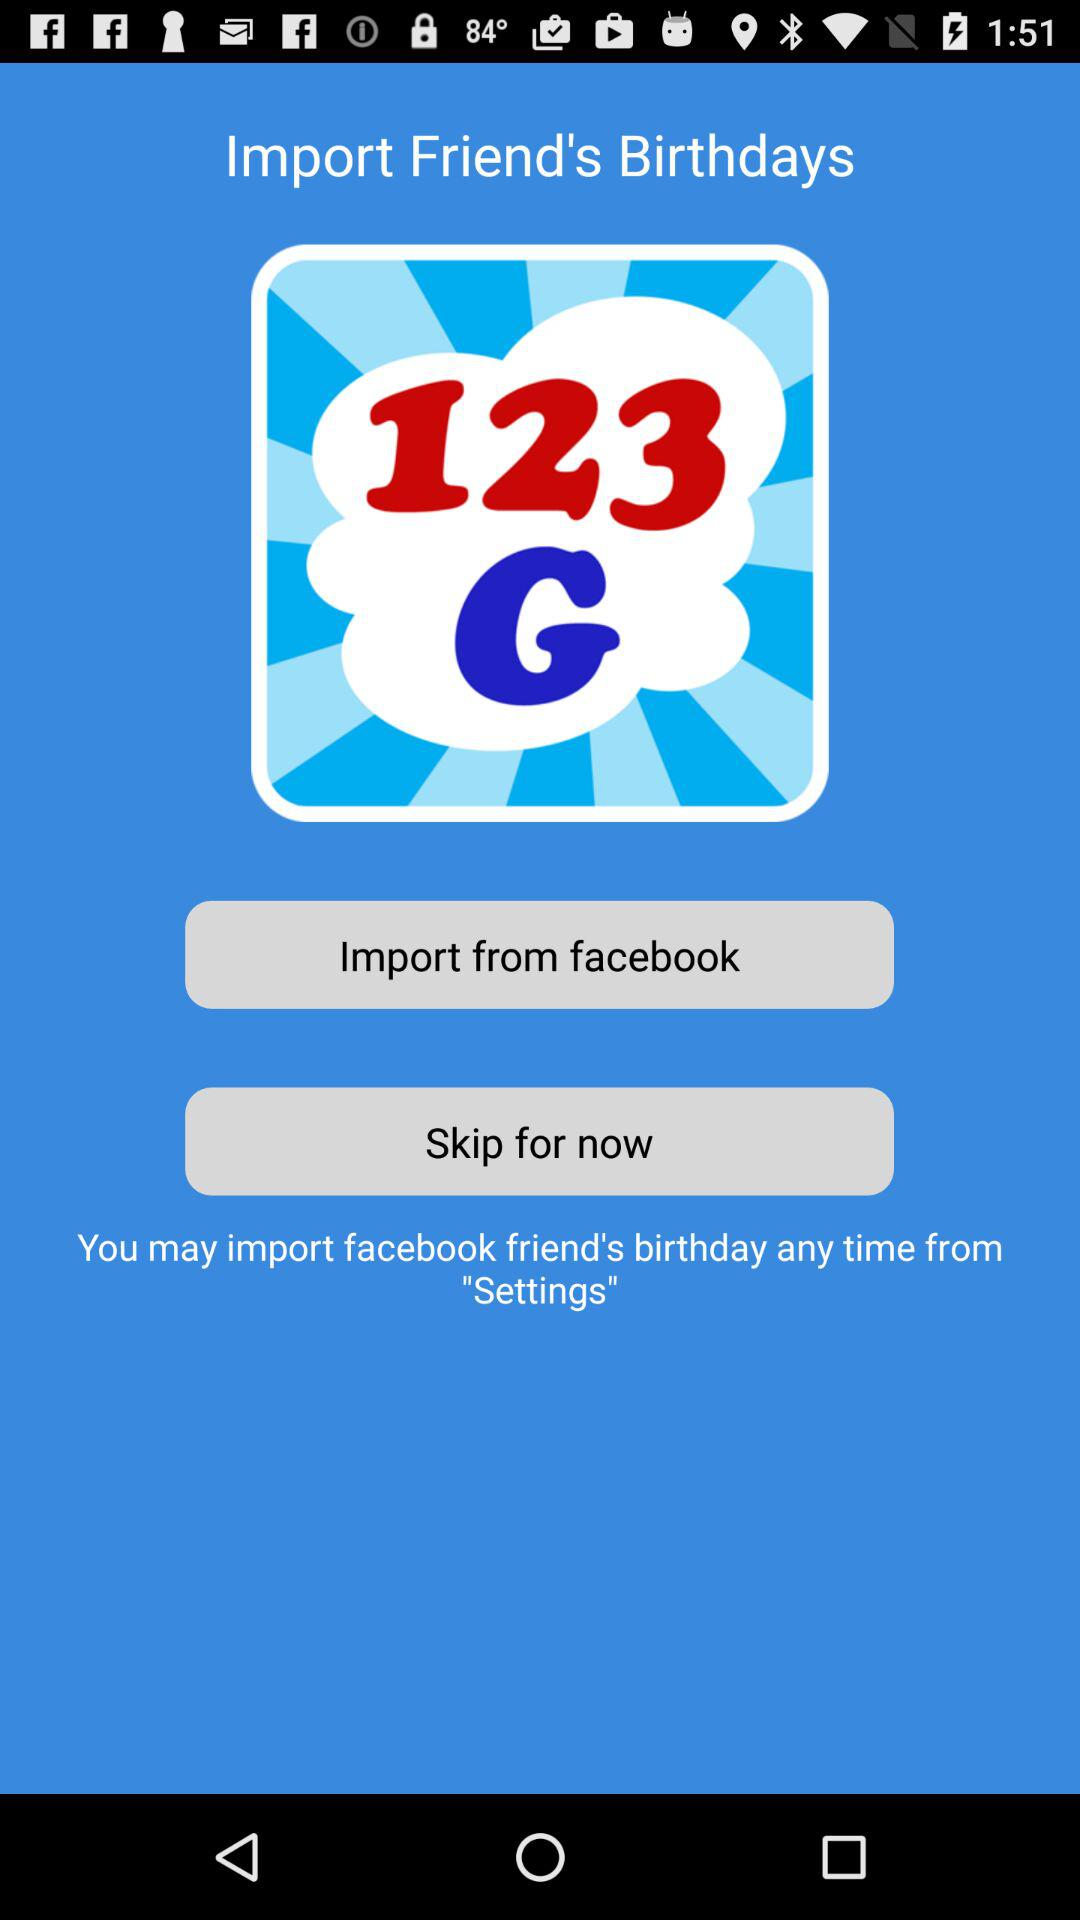From where can a friend's birthday be imported? A friend's birthday can be imported from "facebook". 